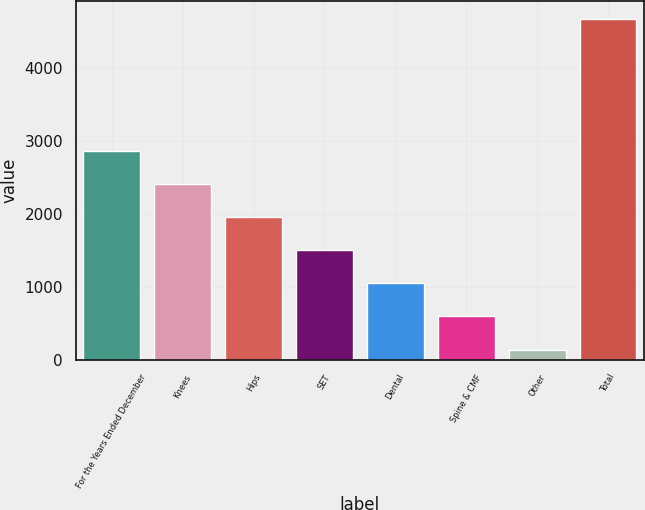Convert chart. <chart><loc_0><loc_0><loc_500><loc_500><bar_chart><fcel>For the Years Ended December<fcel>Knees<fcel>Hips<fcel>SET<fcel>Dental<fcel>Spine & CMF<fcel>Other<fcel>Total<nl><fcel>2859.38<fcel>2405.9<fcel>1952.42<fcel>1498.94<fcel>1045.46<fcel>591.98<fcel>138.5<fcel>4673.3<nl></chart> 